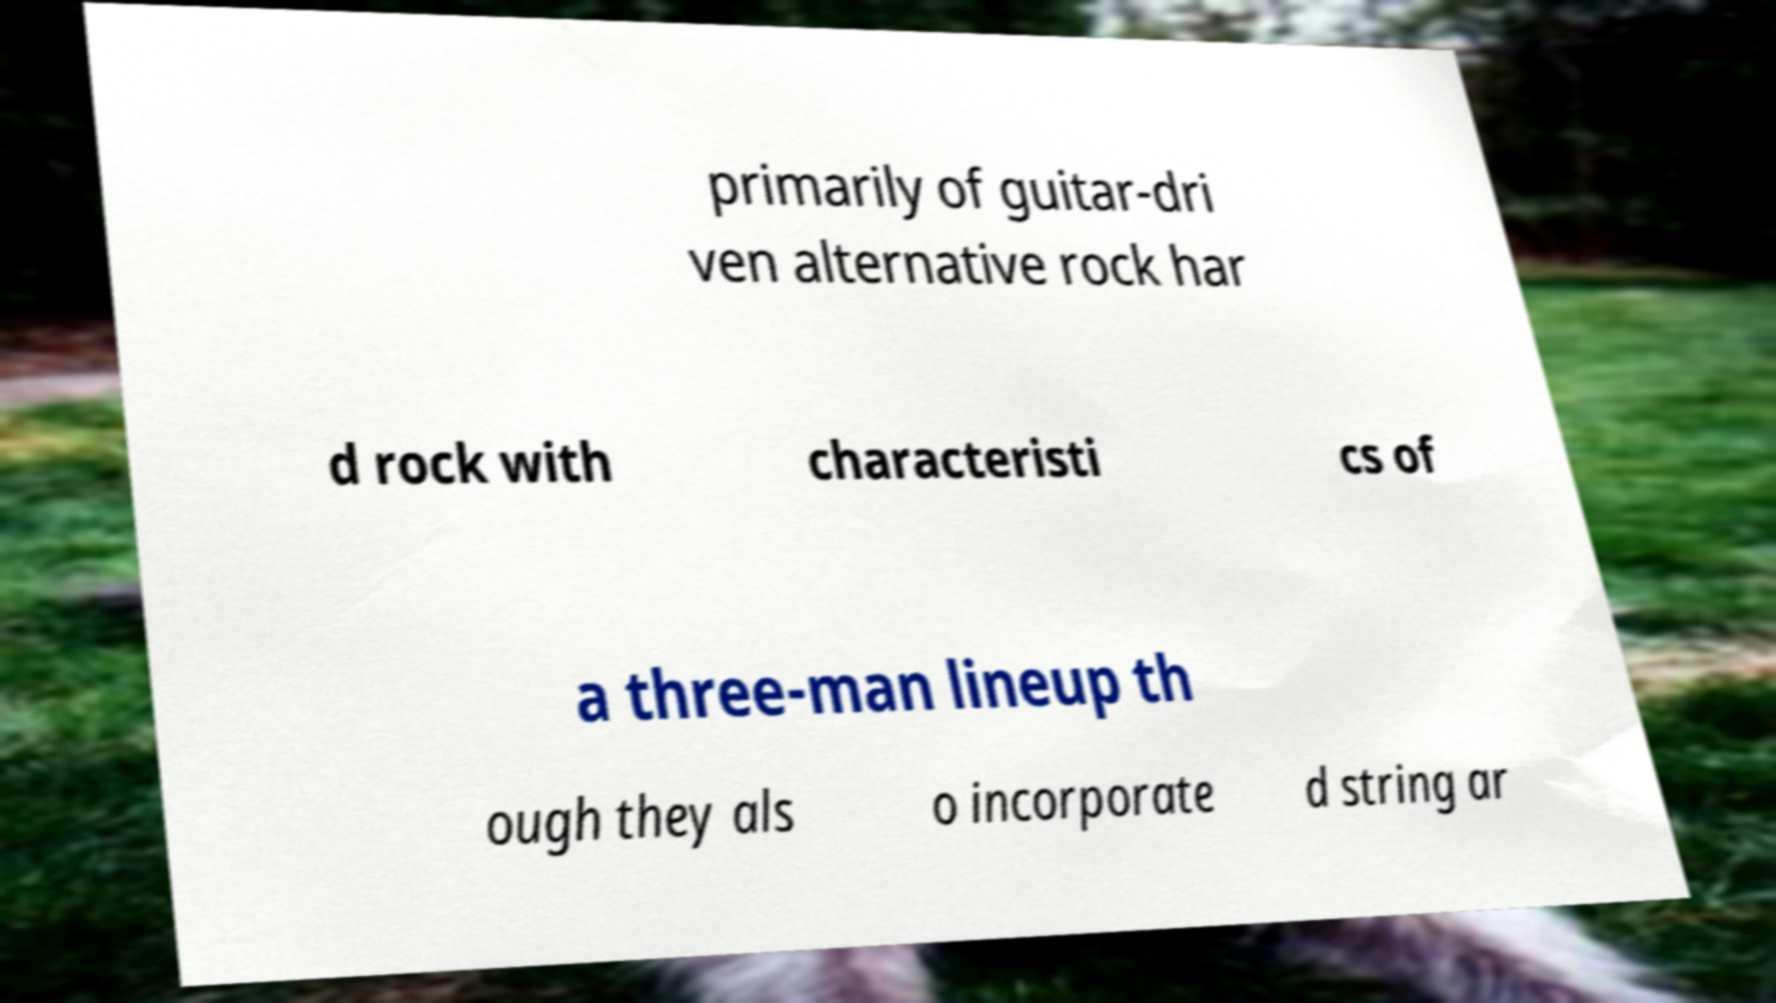Can you accurately transcribe the text from the provided image for me? primarily of guitar-dri ven alternative rock har d rock with characteristi cs of a three-man lineup th ough they als o incorporate d string ar 